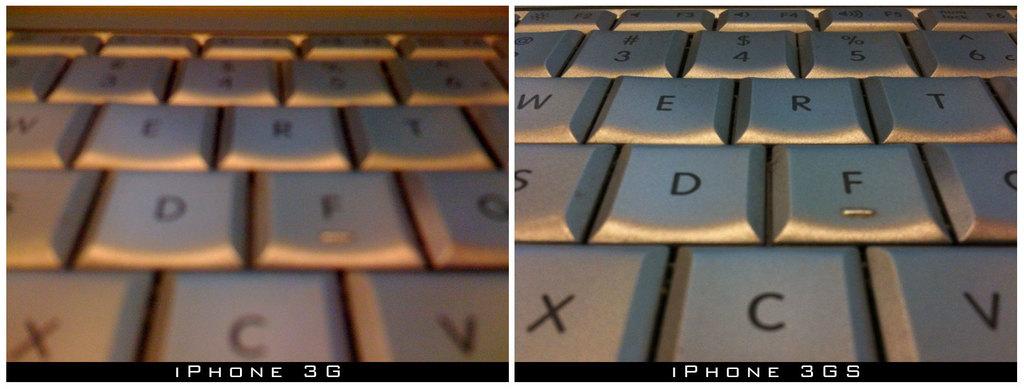Whats the difference in the keyboards?
Provide a short and direct response. S. What is the middle bottom letter?
Provide a short and direct response. C. 